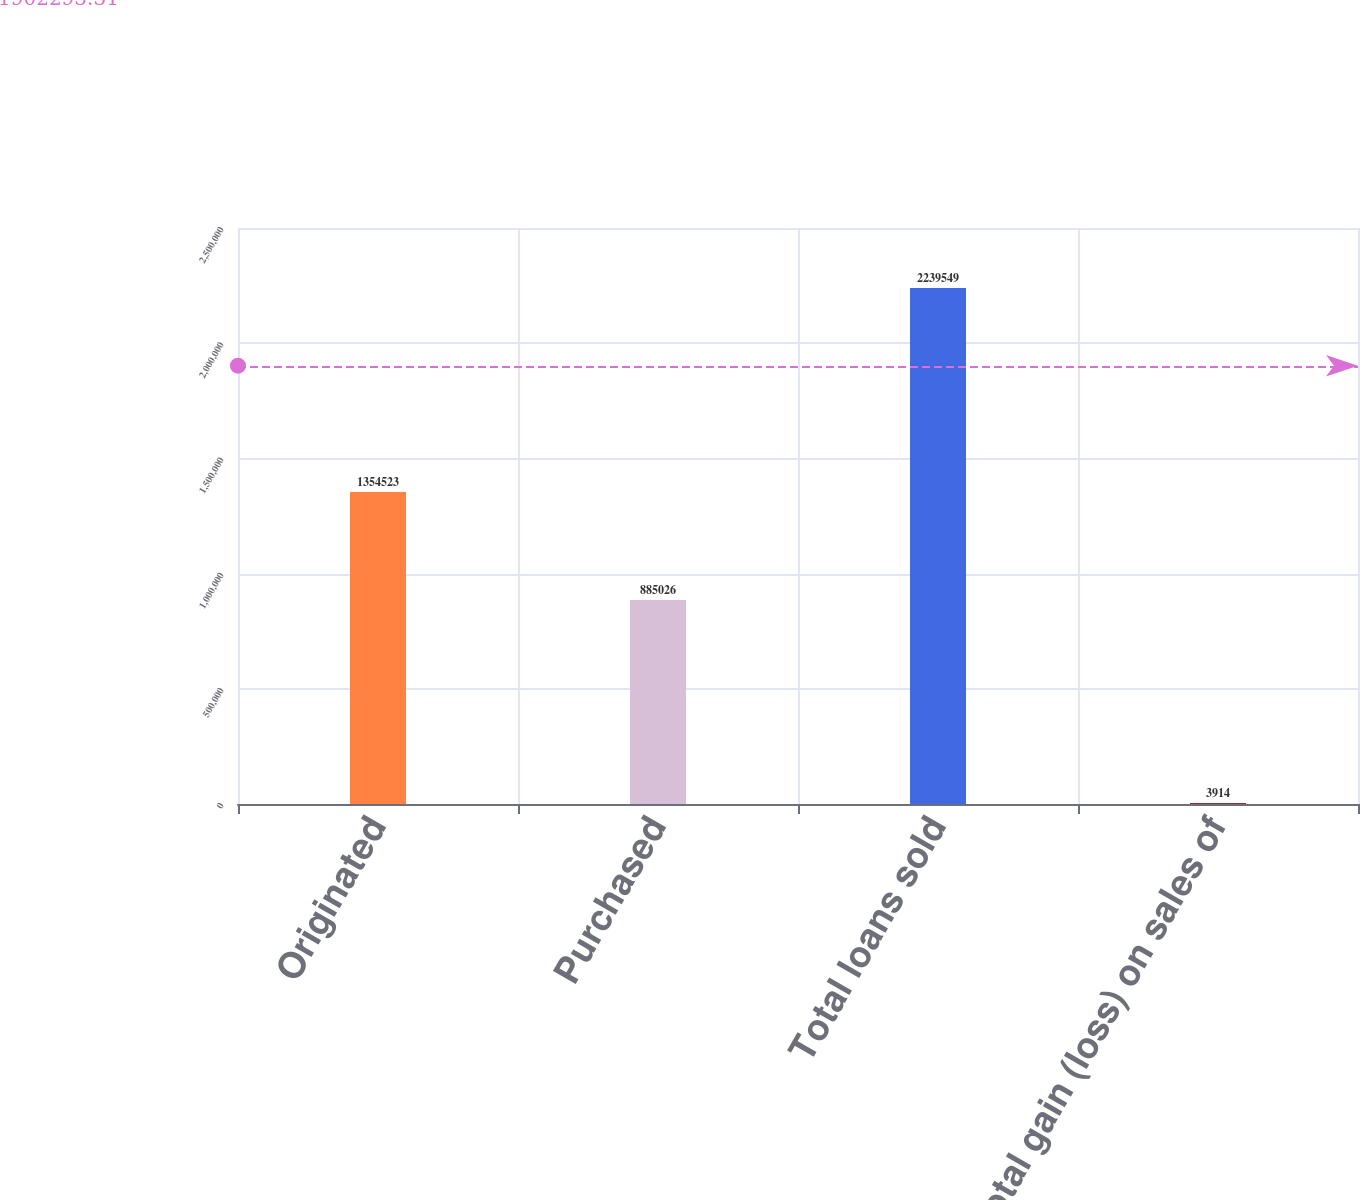Convert chart. <chart><loc_0><loc_0><loc_500><loc_500><bar_chart><fcel>Originated<fcel>Purchased<fcel>Total loans sold<fcel>Total gain (loss) on sales of<nl><fcel>1.35452e+06<fcel>885026<fcel>2.23955e+06<fcel>3914<nl></chart> 